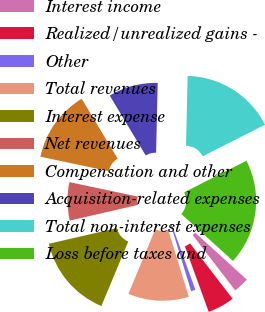Convert chart. <chart><loc_0><loc_0><loc_500><loc_500><pie_chart><fcel>Interest income<fcel>Realized/unrealized gains -<fcel>Other<fcel>Total revenues<fcel>Interest expense<fcel>Net revenues<fcel>Compensation and other<fcel>Acquisition-related expenses<fcel>Total non-interest expenses<fcel>Loss before taxes and<nl><fcel>2.84%<fcel>4.89%<fcel>0.8%<fcel>11.02%<fcel>15.11%<fcel>6.93%<fcel>13.07%<fcel>8.98%<fcel>17.16%<fcel>19.2%<nl></chart> 